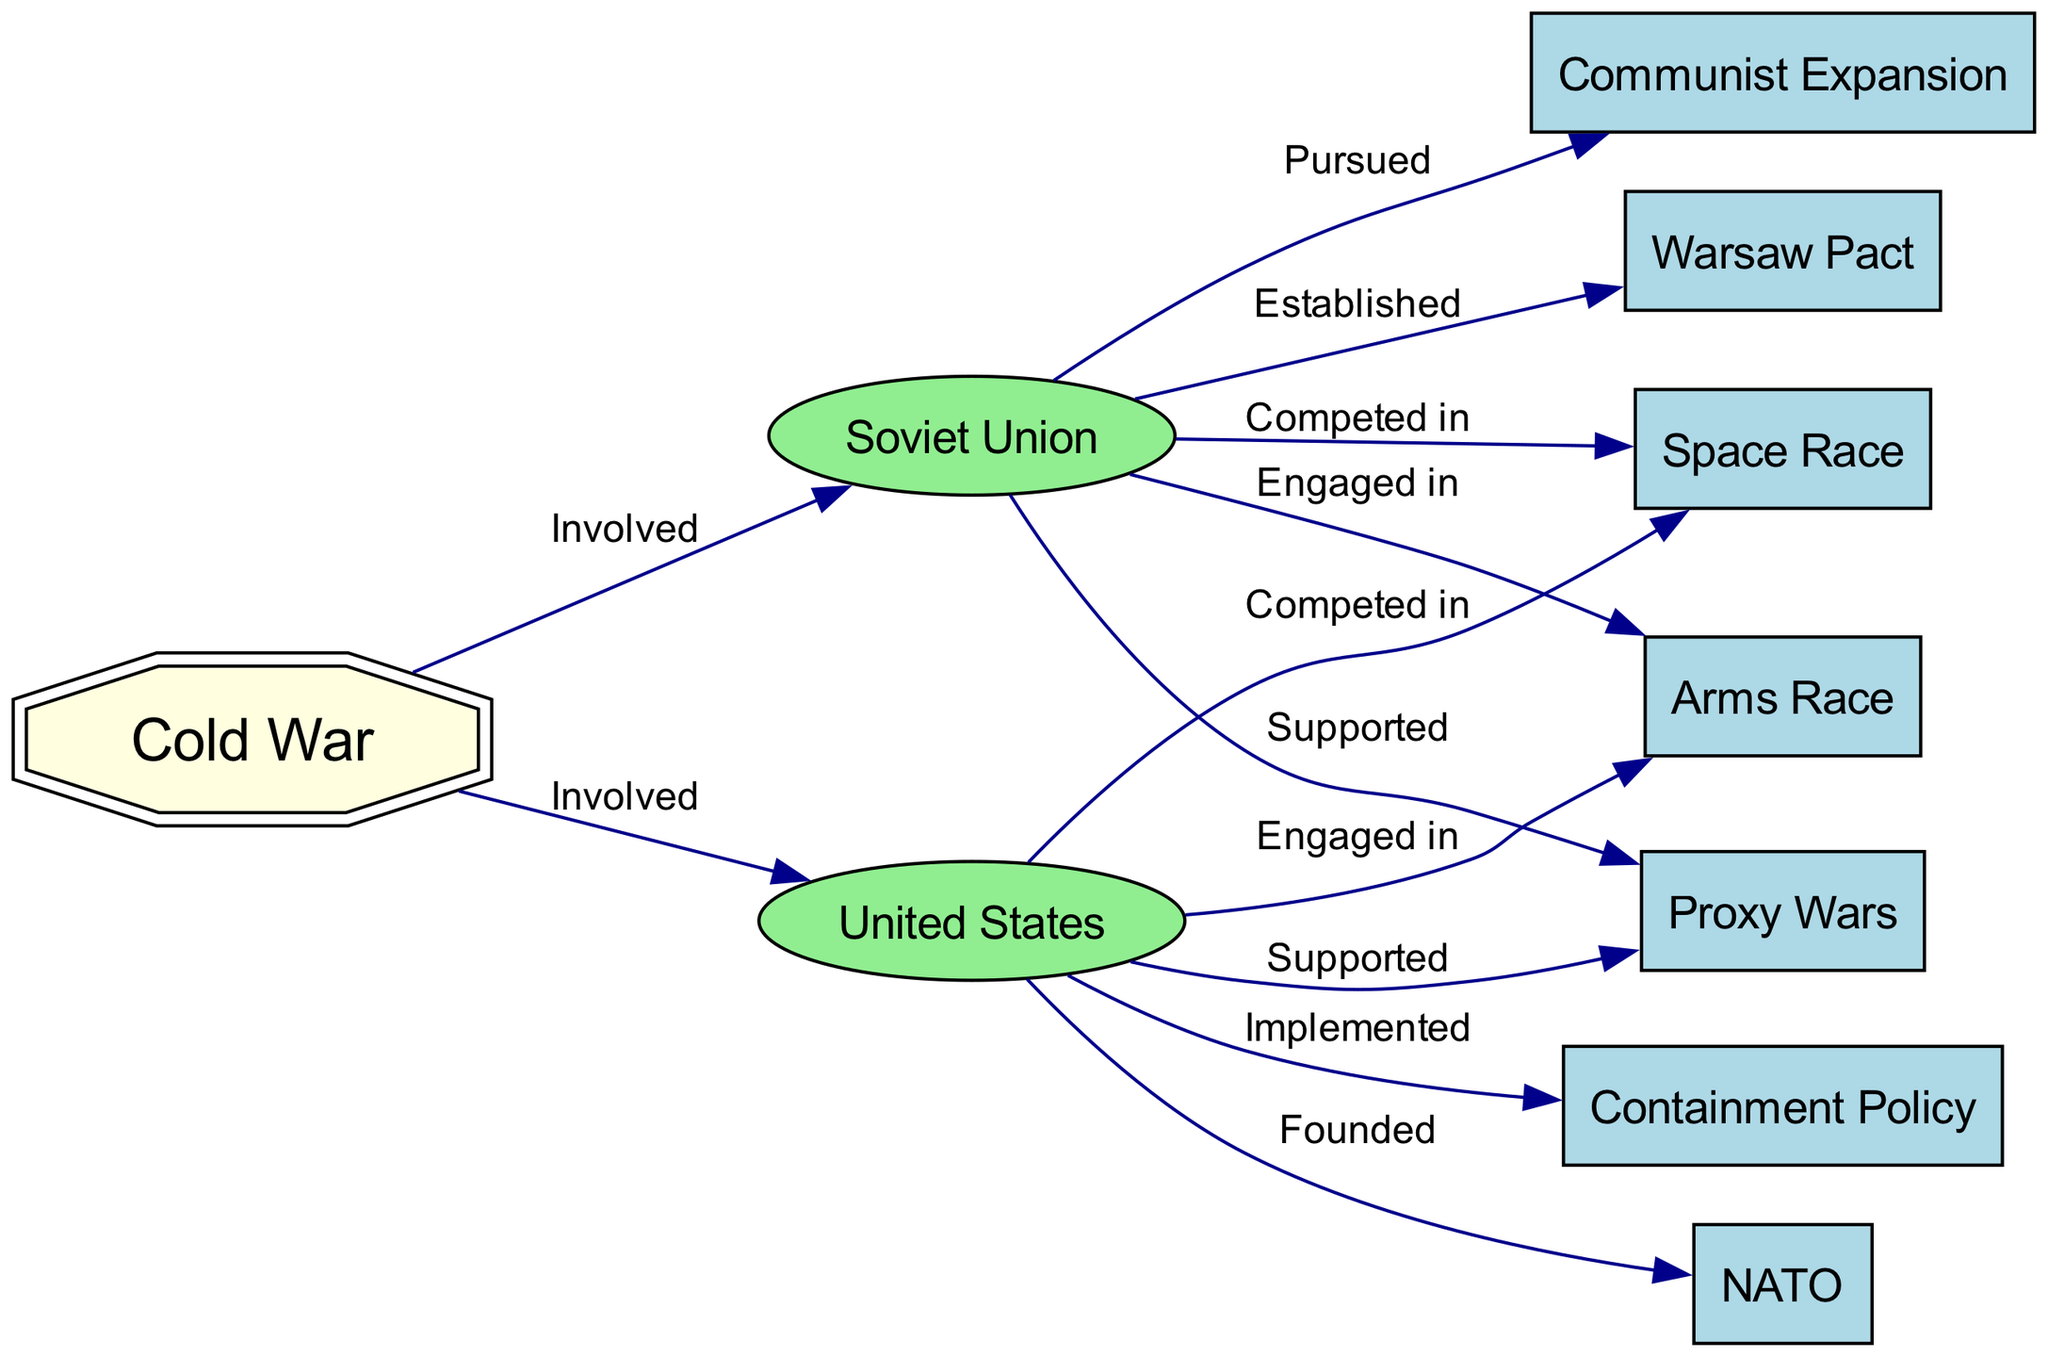What are the two main nations involved in the Cold War? The diagram identifies two primary nations involved in the Cold War, explicitly labeled as "Soviet Union" and "United States." These labels clearly indicate their roles in the conflict.
Answer: Soviet Union, United States How many edges are present in the diagram? By counting the lines connecting the nodes in the diagram, we find a total of 12 edges, representing relationships between different entities related to the Cold War.
Answer: 12 What policy did the United States implement during the Cold War? The diagram indicates that the United States "Implemented" the "Containment Policy," directly linking these two nodes in the flow of the diagram.
Answer: Containment Policy Which organization was founded by the United States? The diagram connects the United States to "NATO," signifying that the U.S. had a role in founding this organization during the Cold War.
Answer: NATO What is the relationship between the Soviet Union and the Warsaw Pact? The diagram specifically states that the Soviet Union "Established" the "Warsaw Pact," directly illustrating their involvement in forming this military alliance.
Answer: Established What do both the Soviet Union and the United States compete in, according to the diagram? The diagram shows a relationship where both the Soviet Union and the United States "Competed in" the "Space Race," indicating a shared area of competition, highlighted by the connections between the respective nodes.
Answer: Space Race Which two activities were supported by both the Soviet Union and the United States? In the diagram, both the Soviet Union and the United States are connected to "Proxy Wars" with the label "Supported," showcasing that both nations engaged in these conflicts indirectly during the Cold War.
Answer: Proxy Wars What common activity did both superpowers engage in during the Cold War? The diagram indicates that both superpowers were "Engaged in" the "Arms Race," highlighting a shared focus on military buildup and competition.
Answer: Arms Race 